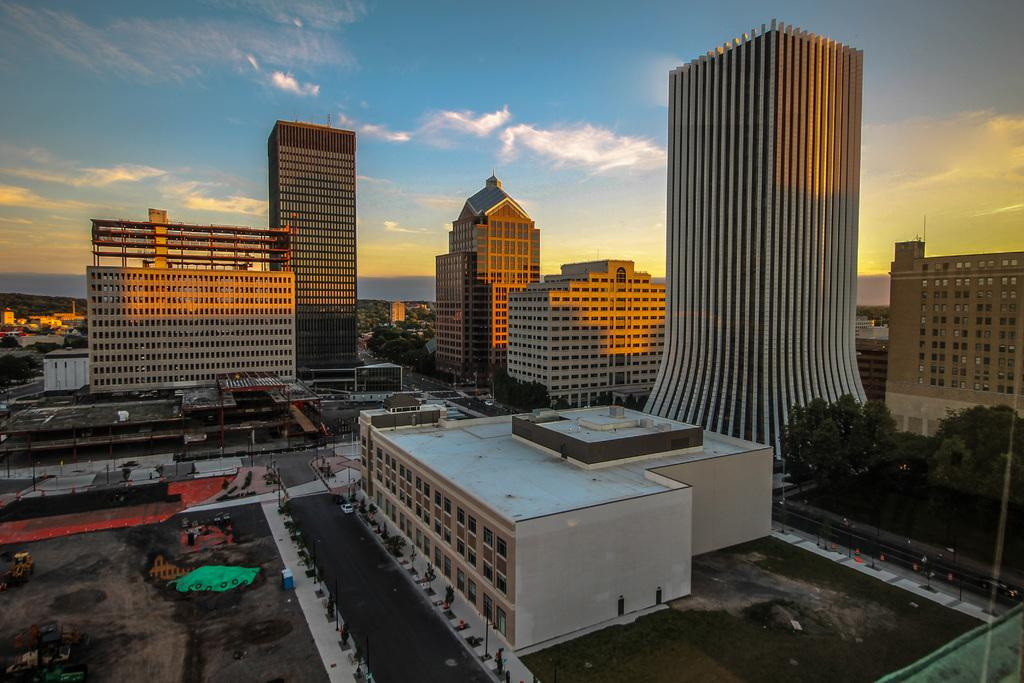What type of structures can be seen in the image? There are buildings in the image. What type of natural elements can be seen in the image? There are trees in the image. What type of man-made elements can be seen in the image? There are vehicles and roads in the image. What type of produce is being harvested in the image? There is no produce being harvested in the image; it features buildings, trees, vehicles, and roads. What type of fire can be seen in the image? There is no fire present in the image. 